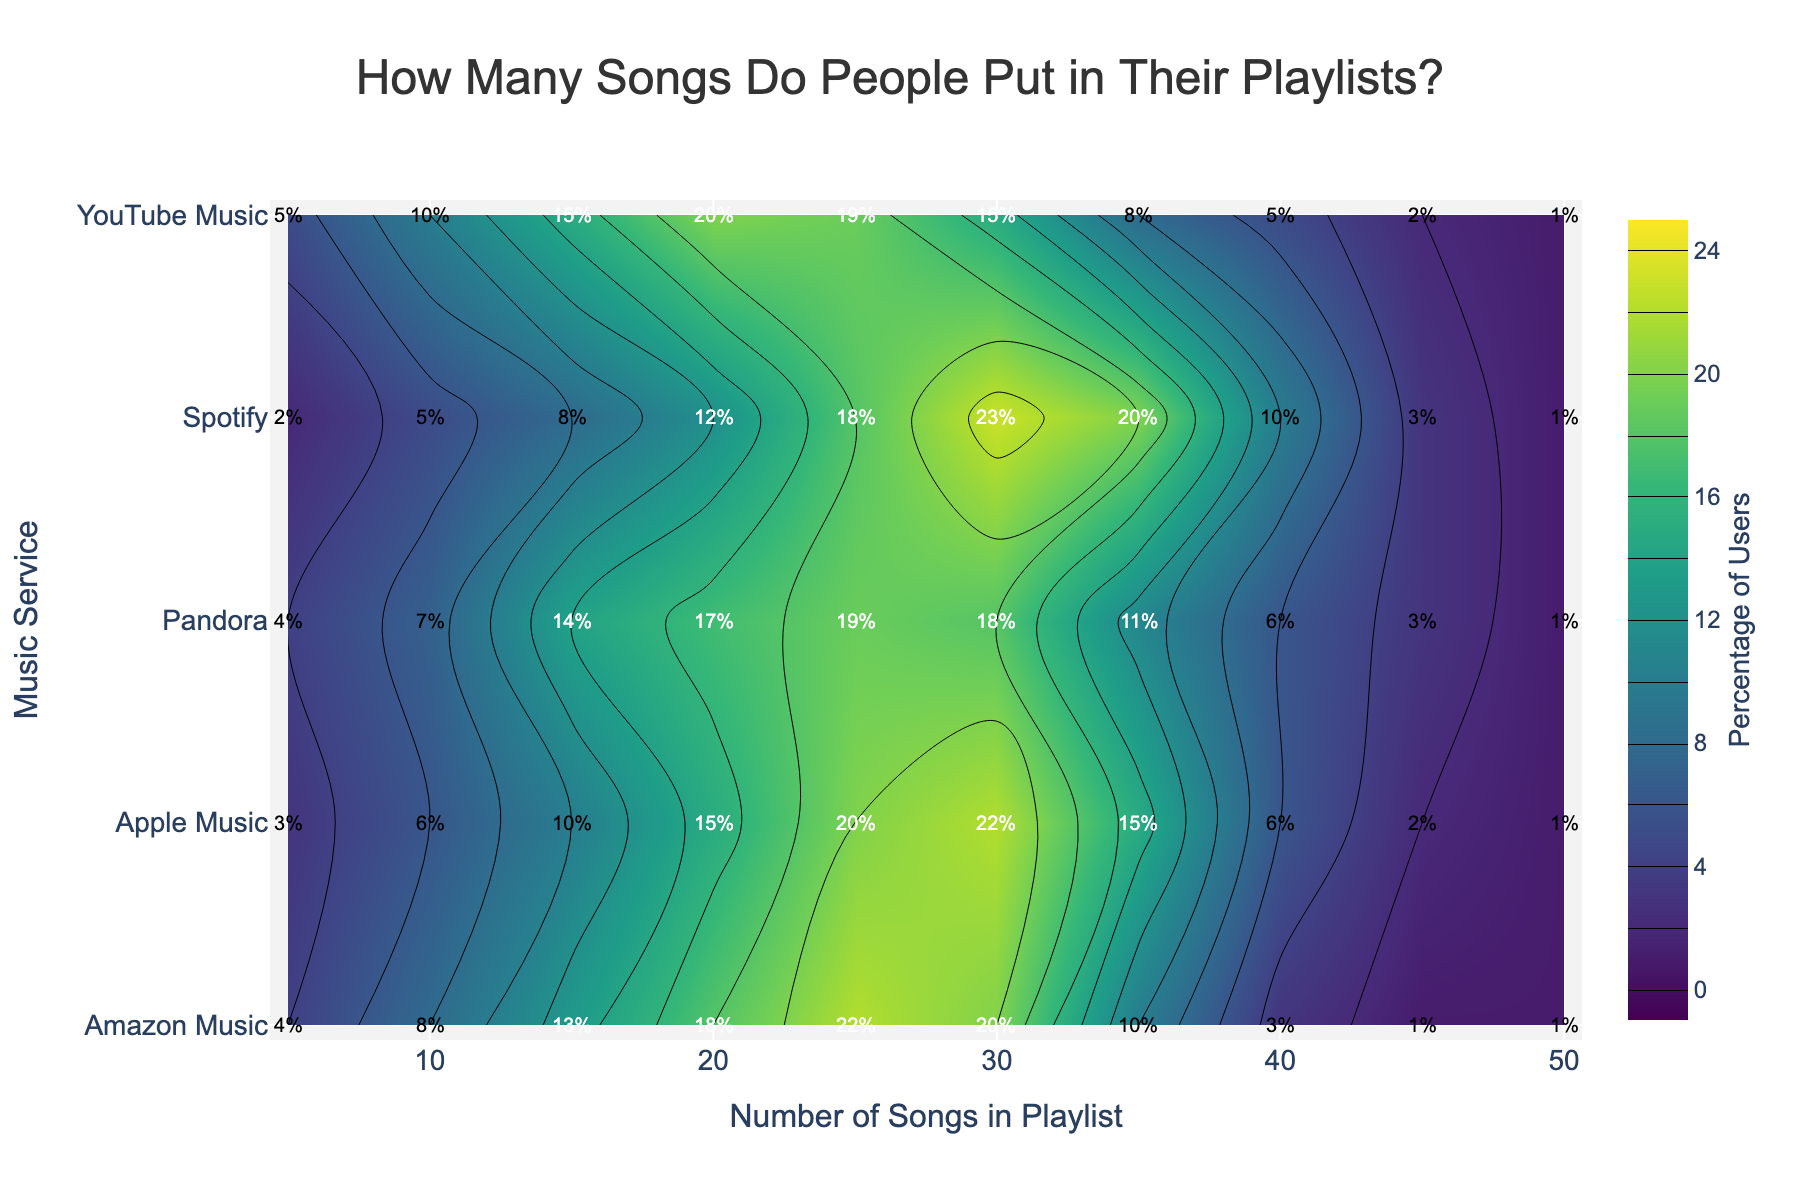What is the highest percentage of users for playlists with 30 songs on Amazon Music? Look at the y-axis for 'Amazon Music' and trace horizontally to the 30 songs mark on the x-axis. Check the color intensity and the labels to find the percentage.
Answer: 20% Which music service has the highest percentage of users with a 25 song playlist? Identify the color intensity and percentage labels at the 25 song mark on the x-axis for each service on the y-axis. The highest value indicates the answer.
Answer: Amazon Music How many services have a noticeable percentage (greater than 10%) of users with 15 songs in their playlists? Find the 15 song mark on the x-axis and check the percentage labels for each service. Count how many percentages are greater than 10%.
Answer: 4 Do Spotify users tend to create longer or shorter playlists? Compare the percentage distribution across different playlist lengths for Spotify. Higher percentages at higher x-axis values indicate longer playlists, and vice versa.
Answer: Longer Which service has the smallest percentage of users for 45-song playlists? Look at the percentage labels at the 45 song mark on the x-axis across all services. Identify the lowest value.
Answer: Amazon Music Which music service shows the most varied distribution of playlist lengths? Examine all services and observe the spread of color intensities and the corresponding percentage labels across different playlists. The service with the widest spread and varied percentages is the most varied.
Answer: Spotify What is the average percentage of users for 20-song playlists across all services? Add the percentages for 20-song playlists from all services: 12% + 15% + 18% + 20% + 17% = 82%. Then divide by the number of services (5). 82 / 5 = 16.4%
Answer: 16.4% Comparing Spotify and YouTube Music, which service has a higher percentage of users with 40-song playlists? Check the percentage labels at the 40-song mark on the x-axis for both Spotify and YouTube Music. The higher value determines the answer.
Answer: Spotify Which service has the most consistent percentage of users across different playlist lengths? Analyze the color intensities and percentage labels for all services. The service with the least variation indicates consistency.
Answer: Apple Music 